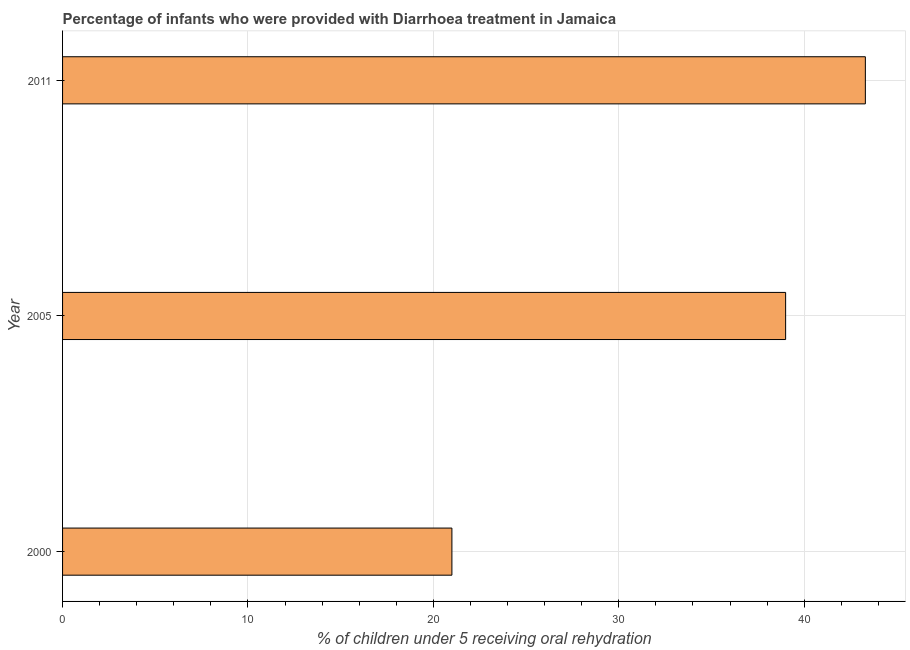Does the graph contain grids?
Make the answer very short. Yes. What is the title of the graph?
Provide a short and direct response. Percentage of infants who were provided with Diarrhoea treatment in Jamaica. What is the label or title of the X-axis?
Offer a very short reply. % of children under 5 receiving oral rehydration. What is the label or title of the Y-axis?
Your answer should be compact. Year. What is the percentage of children who were provided with treatment diarrhoea in 2011?
Provide a succinct answer. 43.3. Across all years, what is the maximum percentage of children who were provided with treatment diarrhoea?
Keep it short and to the point. 43.3. In which year was the percentage of children who were provided with treatment diarrhoea maximum?
Make the answer very short. 2011. In which year was the percentage of children who were provided with treatment diarrhoea minimum?
Provide a short and direct response. 2000. What is the sum of the percentage of children who were provided with treatment diarrhoea?
Your answer should be compact. 103.3. What is the difference between the percentage of children who were provided with treatment diarrhoea in 2000 and 2011?
Provide a succinct answer. -22.3. What is the average percentage of children who were provided with treatment diarrhoea per year?
Give a very brief answer. 34.43. In how many years, is the percentage of children who were provided with treatment diarrhoea greater than 14 %?
Give a very brief answer. 3. What is the ratio of the percentage of children who were provided with treatment diarrhoea in 2000 to that in 2011?
Ensure brevity in your answer.  0.48. Is the percentage of children who were provided with treatment diarrhoea in 2005 less than that in 2011?
Offer a terse response. Yes. What is the difference between the highest and the lowest percentage of children who were provided with treatment diarrhoea?
Offer a terse response. 22.3. Are all the bars in the graph horizontal?
Make the answer very short. Yes. How many years are there in the graph?
Your answer should be compact. 3. Are the values on the major ticks of X-axis written in scientific E-notation?
Ensure brevity in your answer.  No. What is the % of children under 5 receiving oral rehydration in 2005?
Offer a terse response. 39. What is the % of children under 5 receiving oral rehydration of 2011?
Offer a very short reply. 43.3. What is the difference between the % of children under 5 receiving oral rehydration in 2000 and 2005?
Make the answer very short. -18. What is the difference between the % of children under 5 receiving oral rehydration in 2000 and 2011?
Provide a short and direct response. -22.3. What is the ratio of the % of children under 5 receiving oral rehydration in 2000 to that in 2005?
Offer a terse response. 0.54. What is the ratio of the % of children under 5 receiving oral rehydration in 2000 to that in 2011?
Provide a succinct answer. 0.48. What is the ratio of the % of children under 5 receiving oral rehydration in 2005 to that in 2011?
Offer a very short reply. 0.9. 